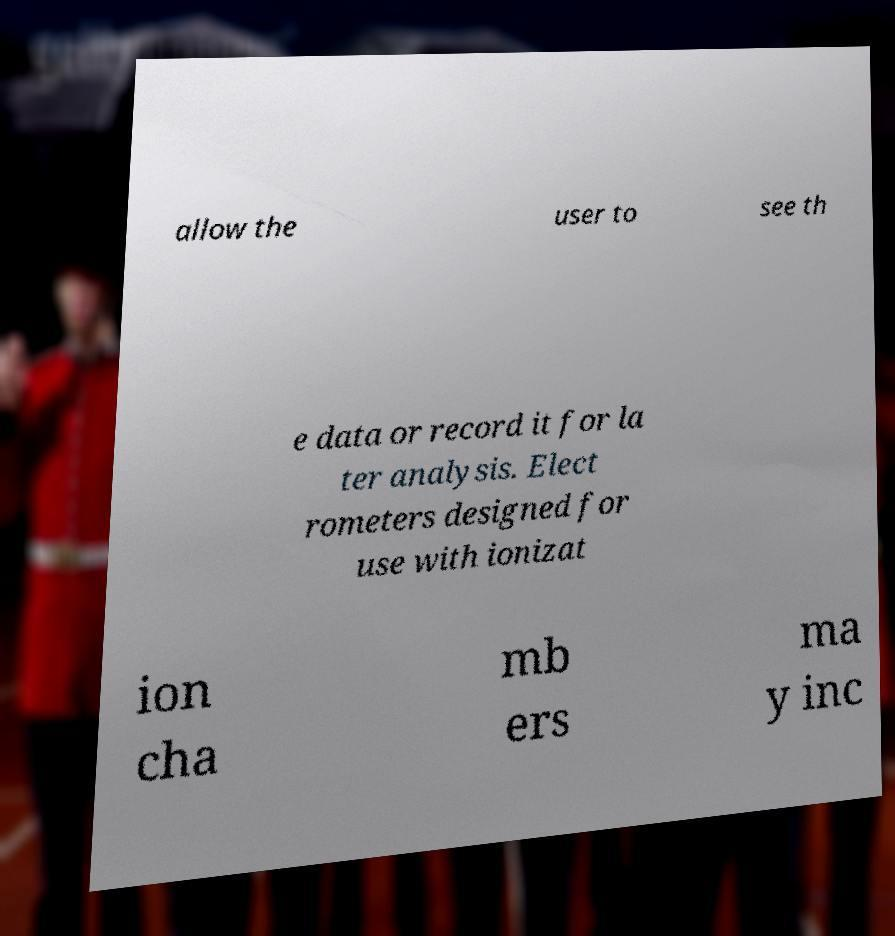There's text embedded in this image that I need extracted. Can you transcribe it verbatim? allow the user to see th e data or record it for la ter analysis. Elect rometers designed for use with ionizat ion cha mb ers ma y inc 